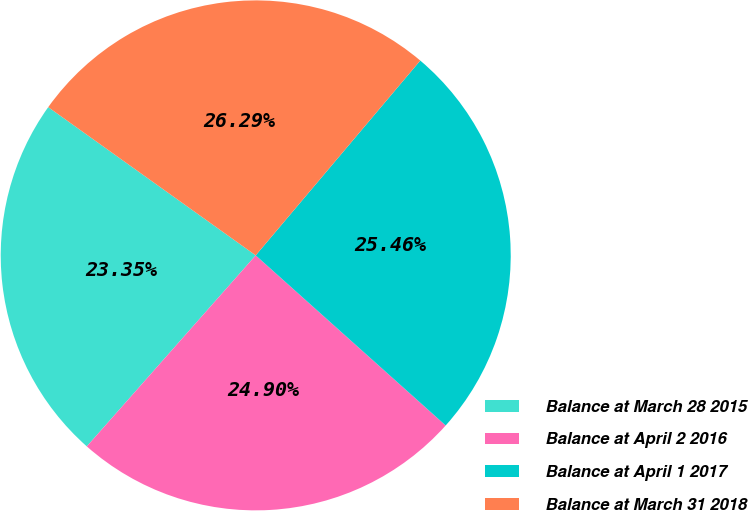Convert chart to OTSL. <chart><loc_0><loc_0><loc_500><loc_500><pie_chart><fcel>Balance at March 28 2015<fcel>Balance at April 2 2016<fcel>Balance at April 1 2017<fcel>Balance at March 31 2018<nl><fcel>23.35%<fcel>24.9%<fcel>25.46%<fcel>26.29%<nl></chart> 